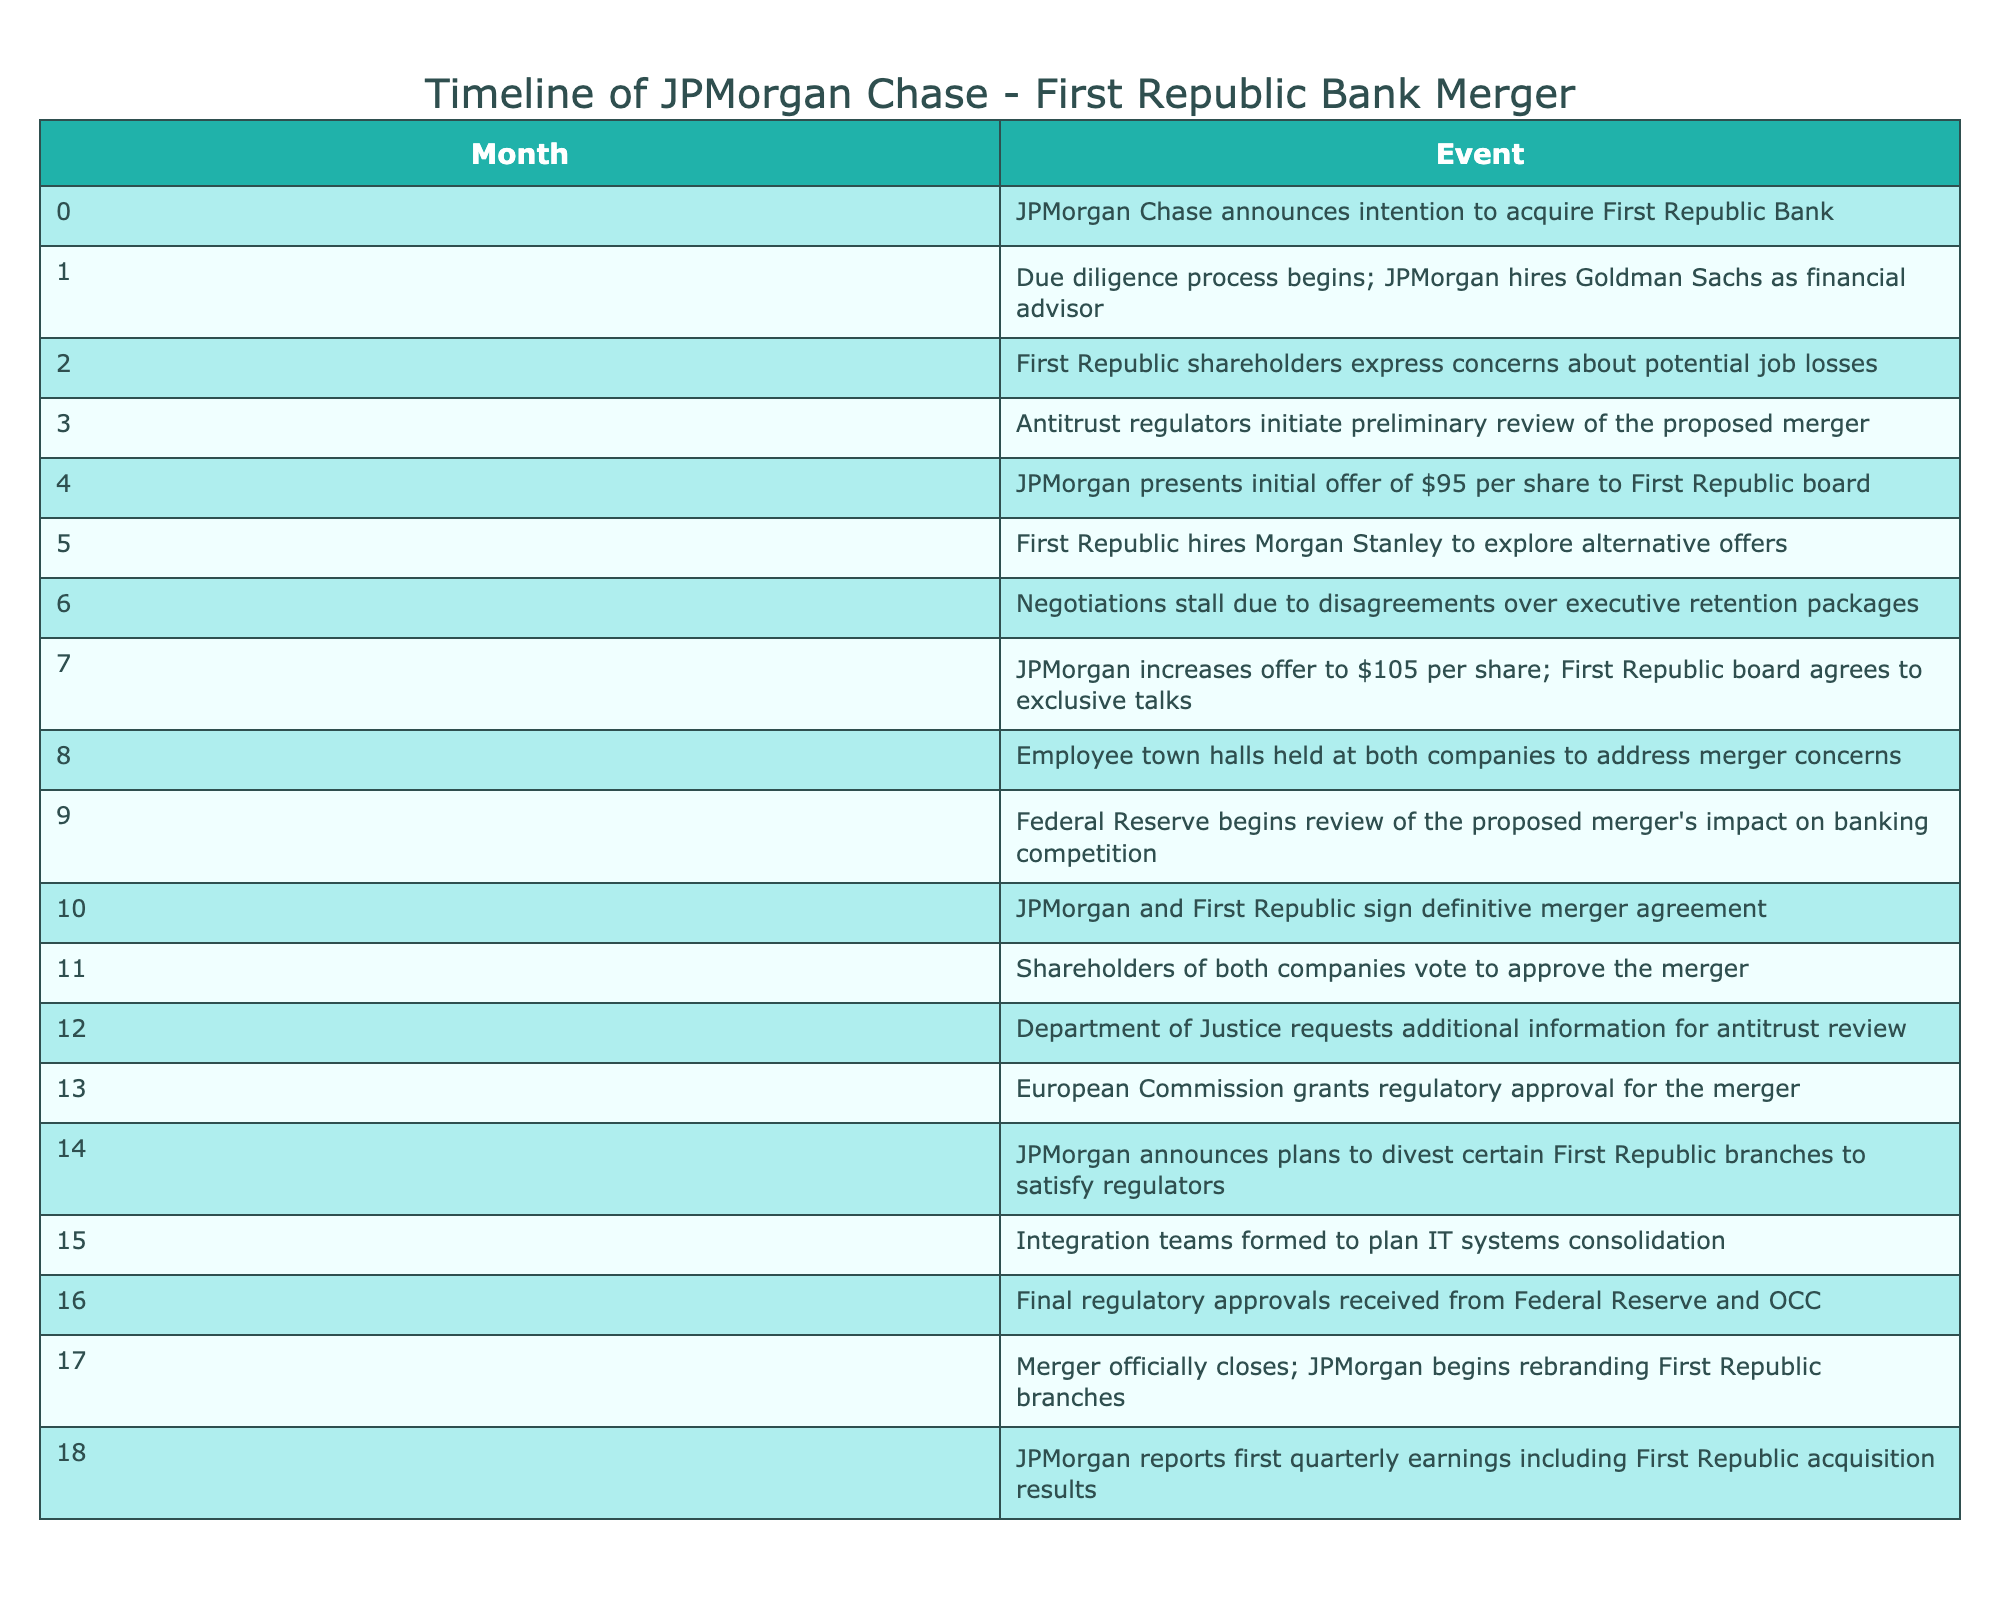What event occurred in month 4? According to the table, in month 4, JPMorgan presented an initial offer of $95 per share to the First Republic board.
Answer: JPMorgan presented initial offer of $95 per share to First Republic board How many months did the due diligence process last? The due diligence process began in month 1 and did not have a specified end month, but it was ongoing until at least month 10 when the definitive merger agreement was signed. If we assume it covered up to the signing, that would be 10 months total.
Answer: 10 months Did the European Commission grant regulatory approval before the Department of Justice requested additional information? Looking at the timeline, the Department of Justice requested additional information in month 12, while the European Commission granted regulatory approval in month 13. Since month 12 comes before month 13, the statement is true.
Answer: Yes What was JPMorgan's final offer per share before the merger agreement was signed? The final offer made by JPMorgan to First Republic was $105 per share, which is recorded in month 7, prior to signing the definitive merger agreement in month 10.
Answer: $105 per share What was the total number of significant events from the initial announcement to the closure of the merger? By counting the total number of events listed from month 0 to month 17, there are 18 significant events marked in the timeline.
Answer: 18 events How many months passed between the initial announcement and the final closure of the merger? The timeline indicates the initial announcement occurred in month 0 and the merger closed in month 17. Therefore, the total duration is 17 months from the beginning to the closing.
Answer: 17 months What actions were taken by First Republic Bank in response to the potential merger within the first three months? In the first three months, First Republic's shareholders expressed concerns about job losses (month 2) and hired Morgan Stanley to explore alternative offers (month 5), indicating a defensive strategy amid merger discussions.
Answer: Concerns about job losses and hiring Morgan Stanley for alternatives Did JPMorgan increase its offer after negotiations stalled? Yes, the table indicates that negotiations stalled in month 6 due to disagreements, but later, JPMorgan increased its offer to $105 per share in month 7, leading to exclusive talks with First Republic.
Answer: Yes How many months did it take for the merger to receive all necessary regulatory approvals? Regulatory approvals were received in month 13 from the European Commission and finalized in month 16 from the Federal Reserve and the OCC. This means it took 3 additional months from month 10 when the merger agreement was signed to final approvals at month 16.
Answer: 3 months 